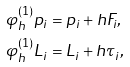Convert formula to latex. <formula><loc_0><loc_0><loc_500><loc_500>\varphi ^ { ( 1 ) } _ { h } p _ { i } & = p _ { i } + h F _ { i } , \\ \varphi ^ { ( 1 ) } _ { h } L _ { i } & = L _ { i } + h \tau _ { i } ,</formula> 